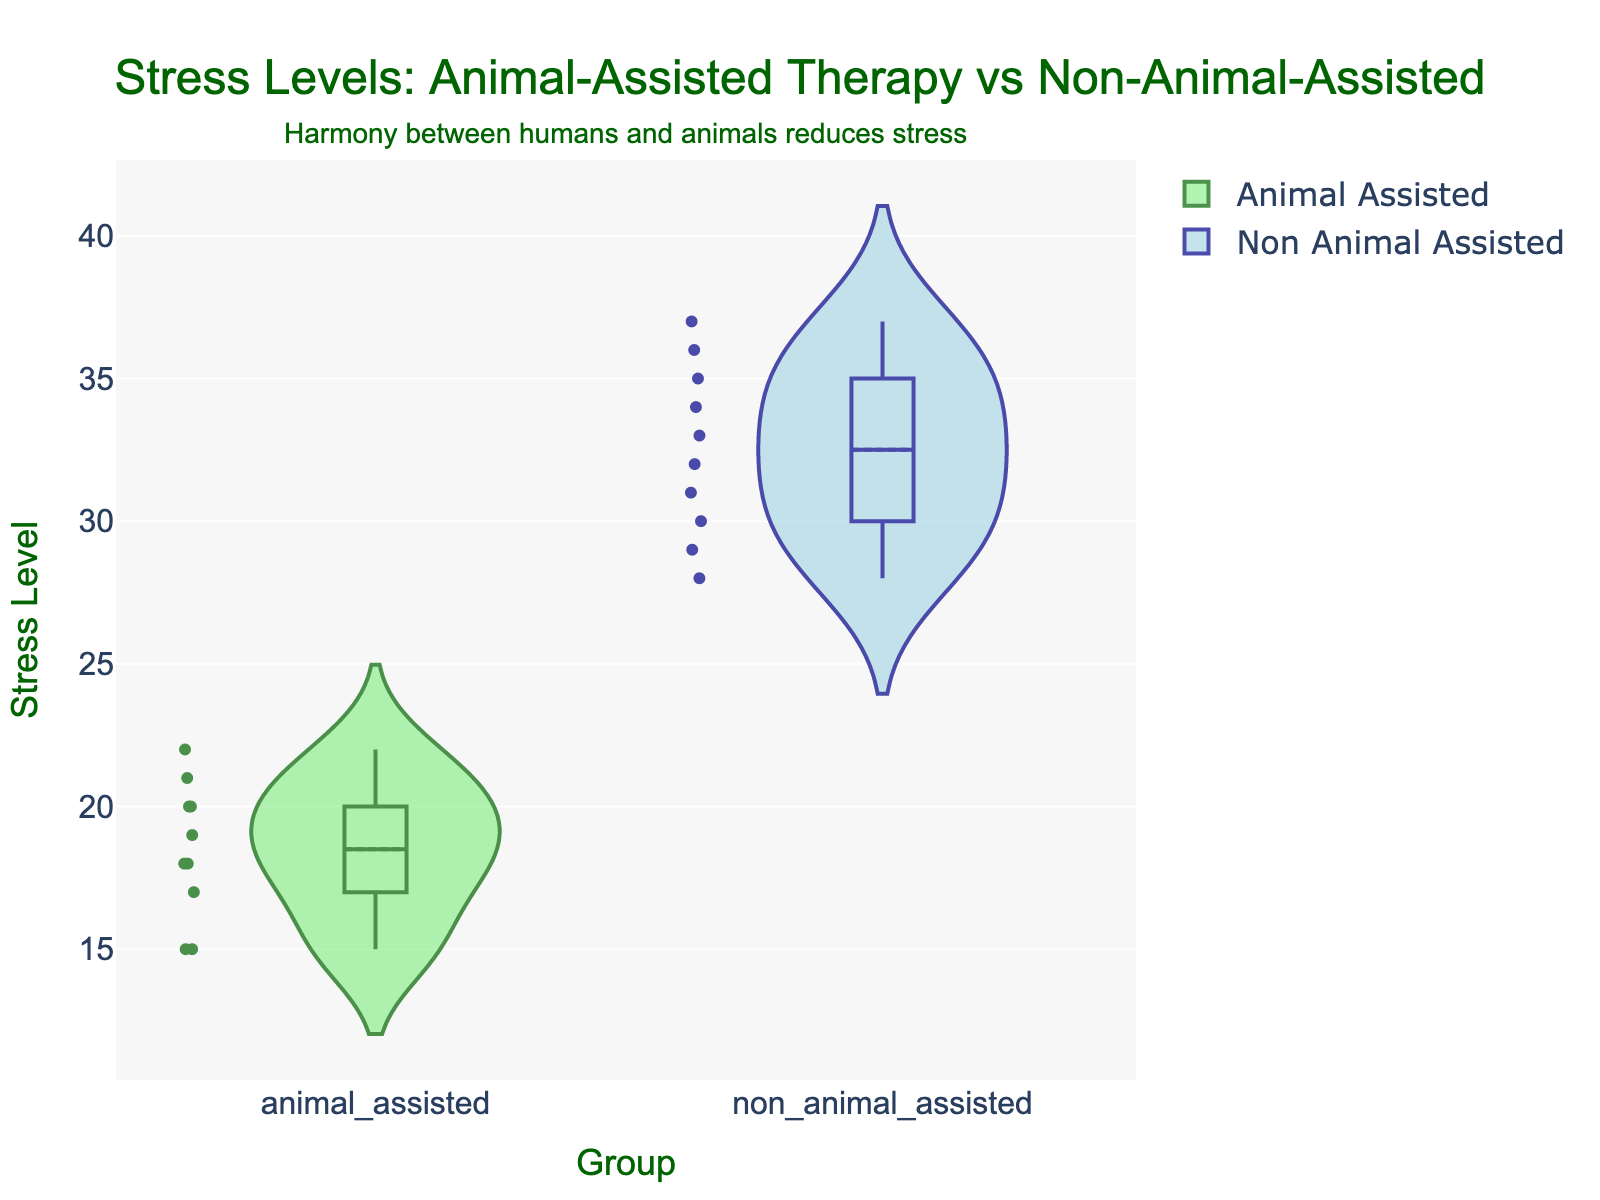What is the title of the figure? The title is located at the top of the figure, usually in a larger font size than other text elements. It provides a summary of what the figure represents.
Answer: Stress Levels: Animal-Assisted Therapy vs Non-Animal-Assisted Which group has a lower median stress level? The median is visually represented by the horizontal line in the middle of the violins. The median line for the animal-assisted group is lower.
Answer: Animal-Assisted Therapy What is the range of stress levels in the non-animal-assisted group? The range is determined by the highest and lowest points in the violin plot for the non-animal-assisted group. Visually, we can see that the stress levels range approximately from 28 to 37.
Answer: 28 to 37 How many groups are compared in the figure? The groups are represented by different colors and positions on the x-axis. From the x-axis labels, it is clear there are two groups being compared.
Answer: Two Which group has more variation in stress levels? Variation in stress levels can be assessed by the width and spread of the violins. The non-animal-assisted group has a wider and more spread violin, indicating higher variation.
Answer: Non-Animal-Assisted Therapy What is the average stress level of the animal-assisted group? The average stress level can be approximated by the position of the meanline visible within the violin. The meanline for the animal-assisted group is located around 18.5.
Answer: 18.5 What additional insight is provided in the annotation? The annotation is a text element usually outside the main plot area providing additional context. It mentions "Harmony between humans and animals reduces stress."
Answer: Harmony between humans and animals reduces stress Is there a visible outlier in any of the groups? Outliers are usually plotted as individual points that are significantly distant from other points in the groups. Upon inspection, no distinct outliers appear to be present in either group.
Answer: No Which group appears to have individuals with consistently higher stress levels? Consistently higher stress levels can be assessed by looking at the overall positioning of the points within the violins. The non-animal-assisted group consistently shows higher stress levels.
Answer: Non-Animal-Assisted Therapy 